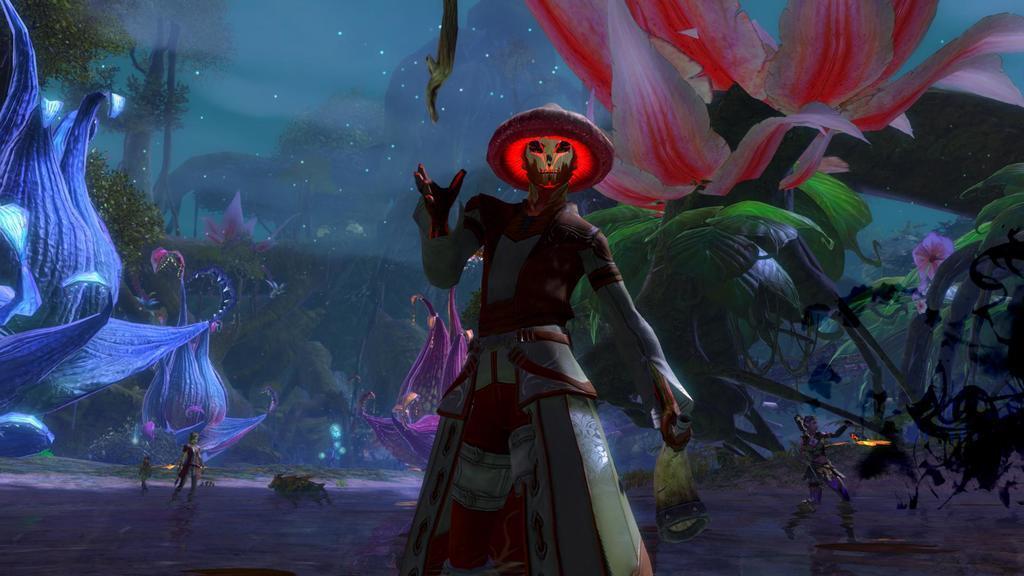Can you describe this image briefly? This is an animated image, in it we can see there are people standing, wearing clothes and this person is wearing a hat. There are trees, flowers and leaves. 